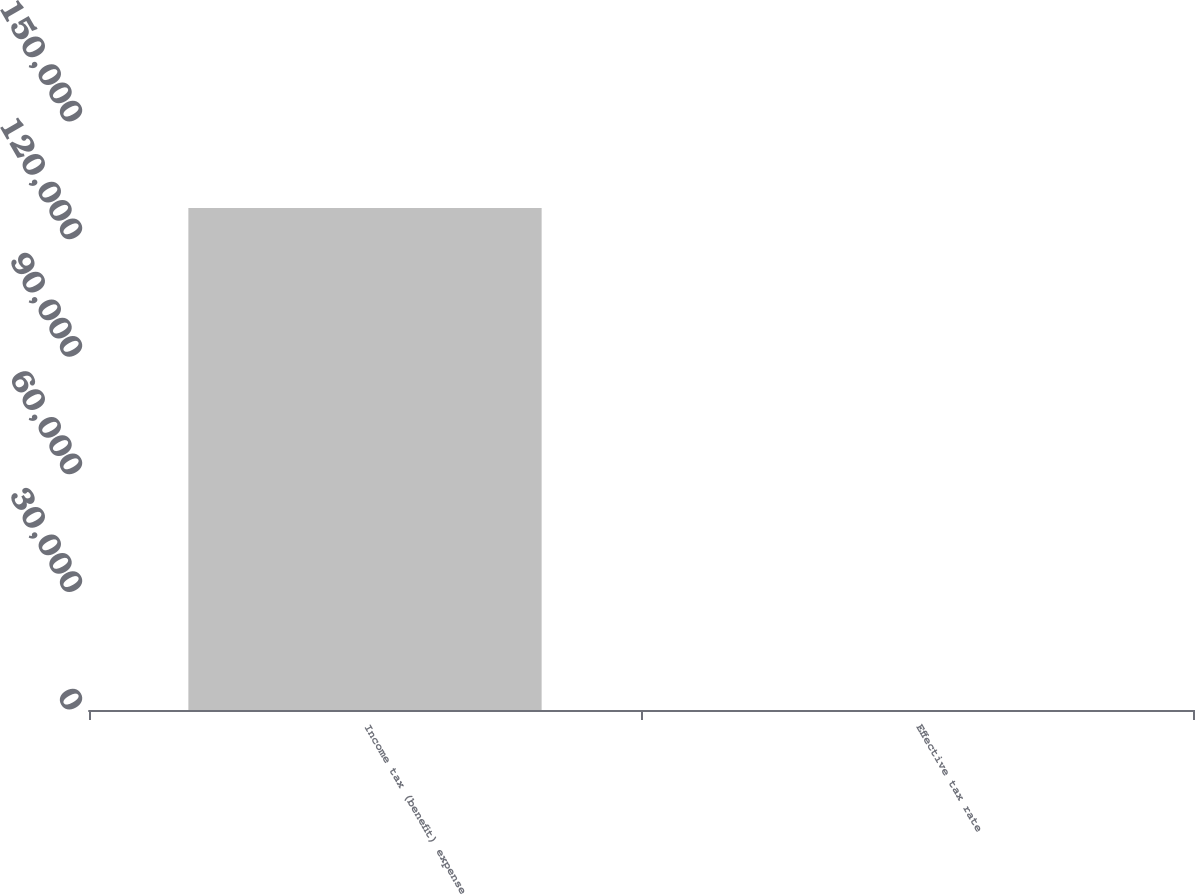Convert chart to OTSL. <chart><loc_0><loc_0><loc_500><loc_500><bar_chart><fcel>Income tax (benefit) expense<fcel>Effective tax rate<nl><fcel>128051<fcel>26<nl></chart> 